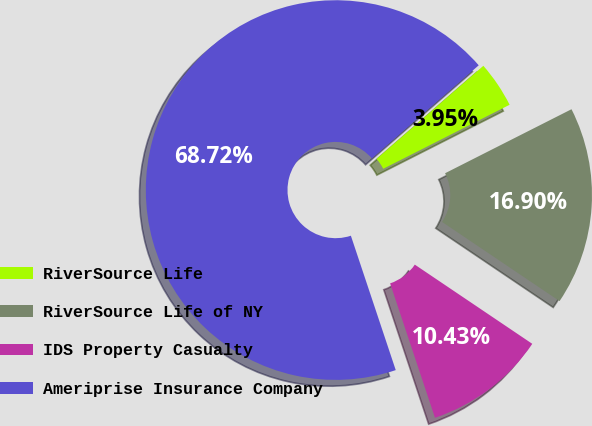Convert chart to OTSL. <chart><loc_0><loc_0><loc_500><loc_500><pie_chart><fcel>RiverSource Life<fcel>RiverSource Life of NY<fcel>IDS Property Casualty<fcel>Ameriprise Insurance Company<nl><fcel>3.95%<fcel>16.9%<fcel>10.43%<fcel>68.71%<nl></chart> 